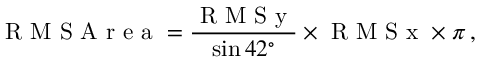Convert formula to latex. <formula><loc_0><loc_0><loc_500><loc_500>R M S A r e a = \frac { R M S y } { \sin 4 2 ^ { \circ } } \times R M S x \times \pi \, ,</formula> 